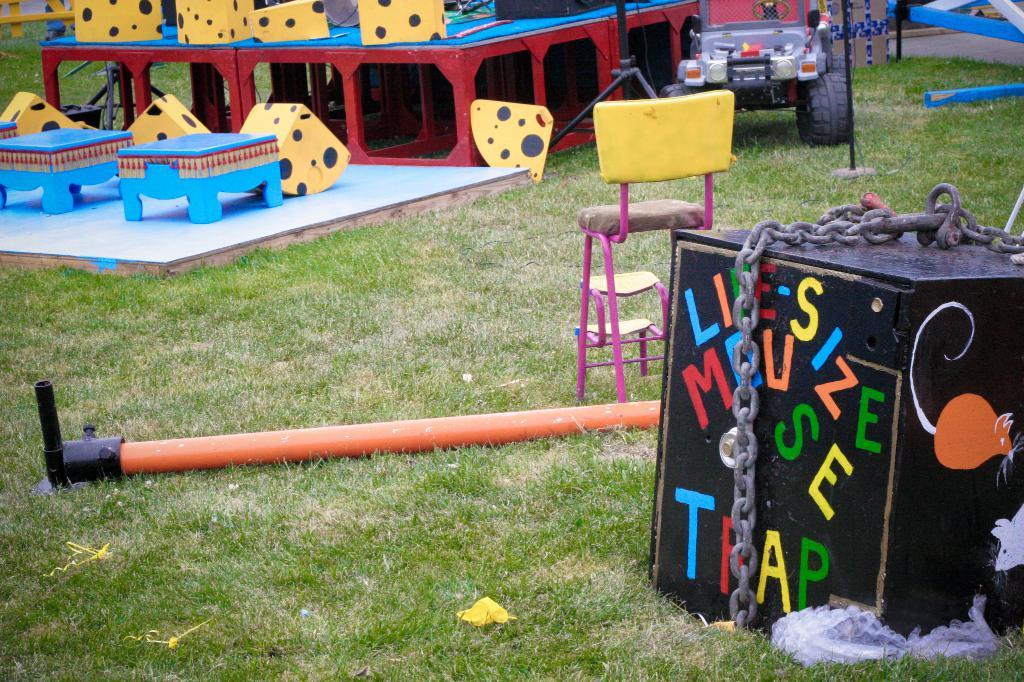What type of area is depicted in the image? The image appears to be a kids play zone. What vehicle is present in the play zone? There is a small jeep in the image. What type of seating is available in the play zone? There is a chair in the image. What type of surface is on the ground in the play zone? Grass is present on the ground in the image. What type of container is present in the play zone? There is a box with a chain in the image. What type of structure is present on the ground in the play zone? There is a metal pole on the ground in the image. What level of difficulty is the thought depicted in the image? There is no thought depicted in the image, as it is a kids play zone with physical objects and structures. 